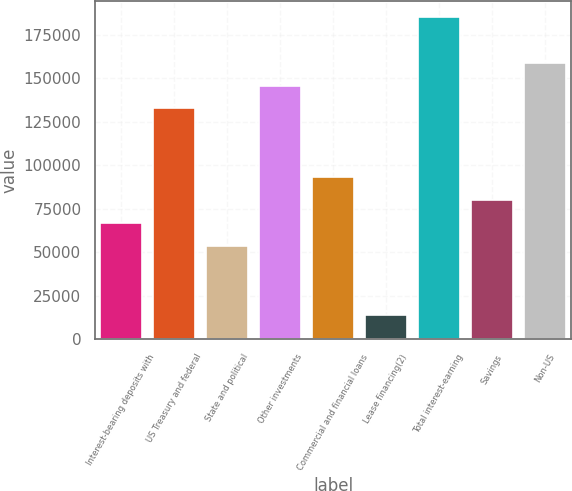Convert chart. <chart><loc_0><loc_0><loc_500><loc_500><bar_chart><fcel>Interest-bearing deposits with<fcel>US Treasury and federal<fcel>State and political<fcel>Other investments<fcel>Commercial and financial loans<fcel>Lease financing(2)<fcel>Total interest-earning<fcel>Savings<fcel>Non-US<nl><fcel>66825.5<fcel>132625<fcel>53665.6<fcel>145785<fcel>93145.3<fcel>14185.9<fcel>185265<fcel>79985.4<fcel>158945<nl></chart> 